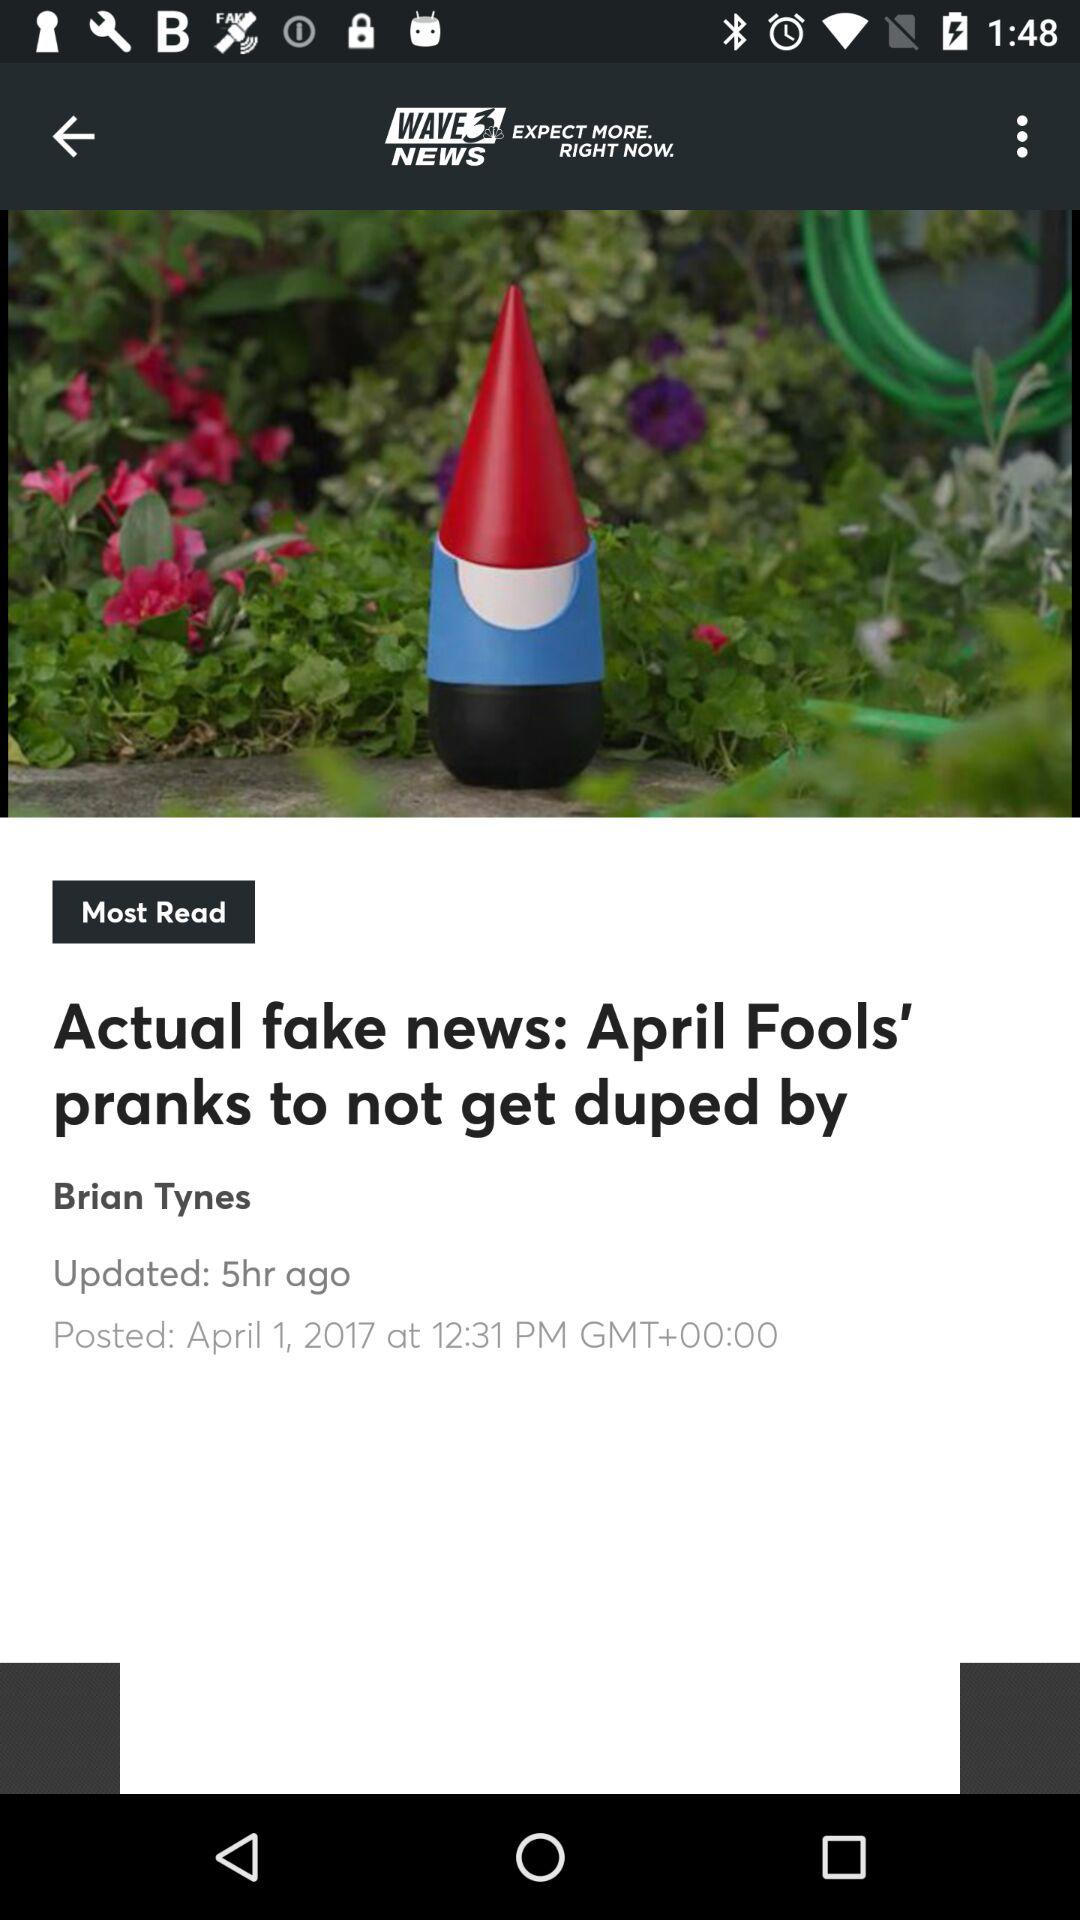How many hours ago was the article posted?
Answer the question using a single word or phrase. 5 